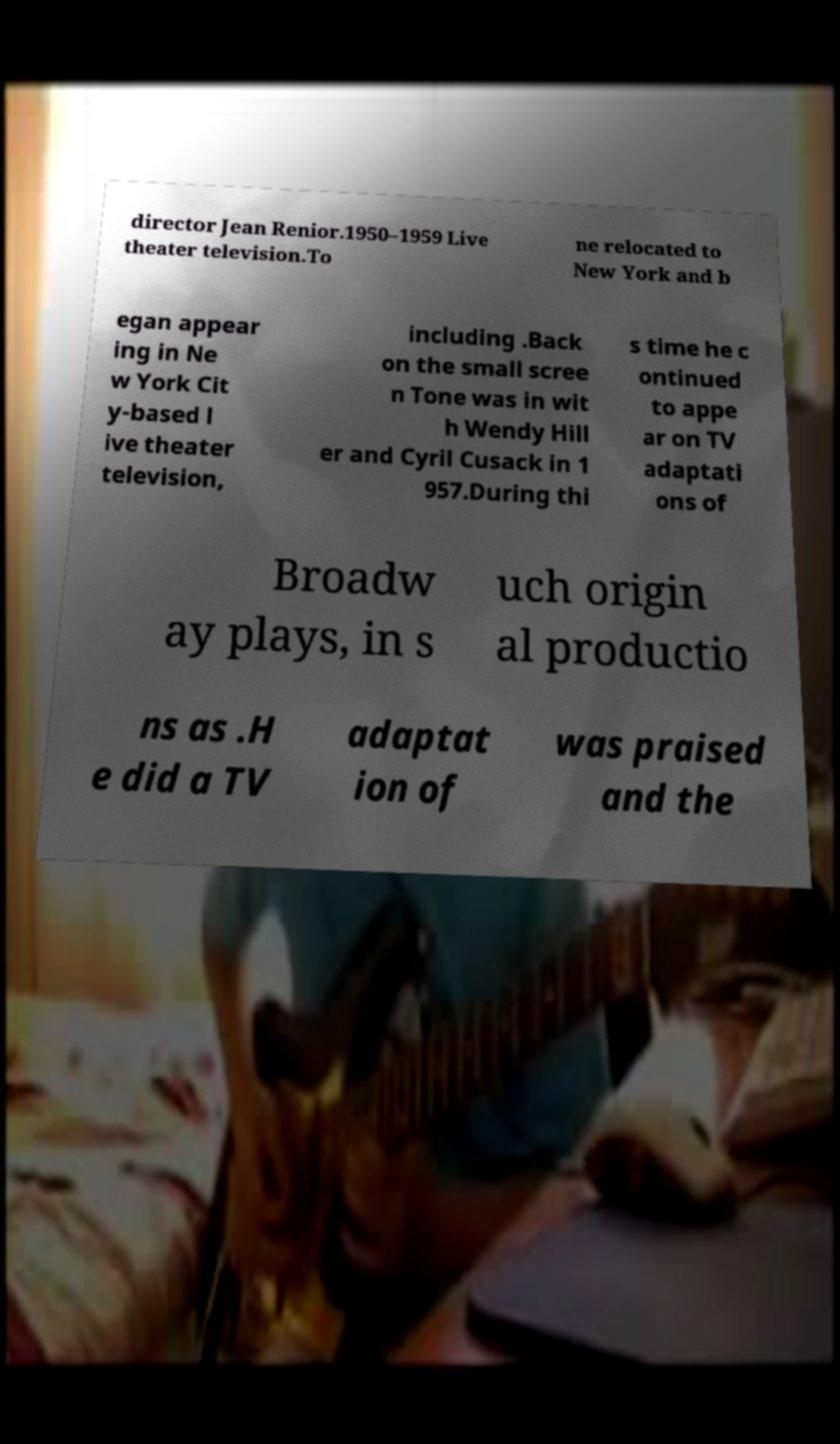There's text embedded in this image that I need extracted. Can you transcribe it verbatim? director Jean Renior.1950–1959 Live theater television.To ne relocated to New York and b egan appear ing in Ne w York Cit y-based l ive theater television, including .Back on the small scree n Tone was in wit h Wendy Hill er and Cyril Cusack in 1 957.During thi s time he c ontinued to appe ar on TV adaptati ons of Broadw ay plays, in s uch origin al productio ns as .H e did a TV adaptat ion of was praised and the 